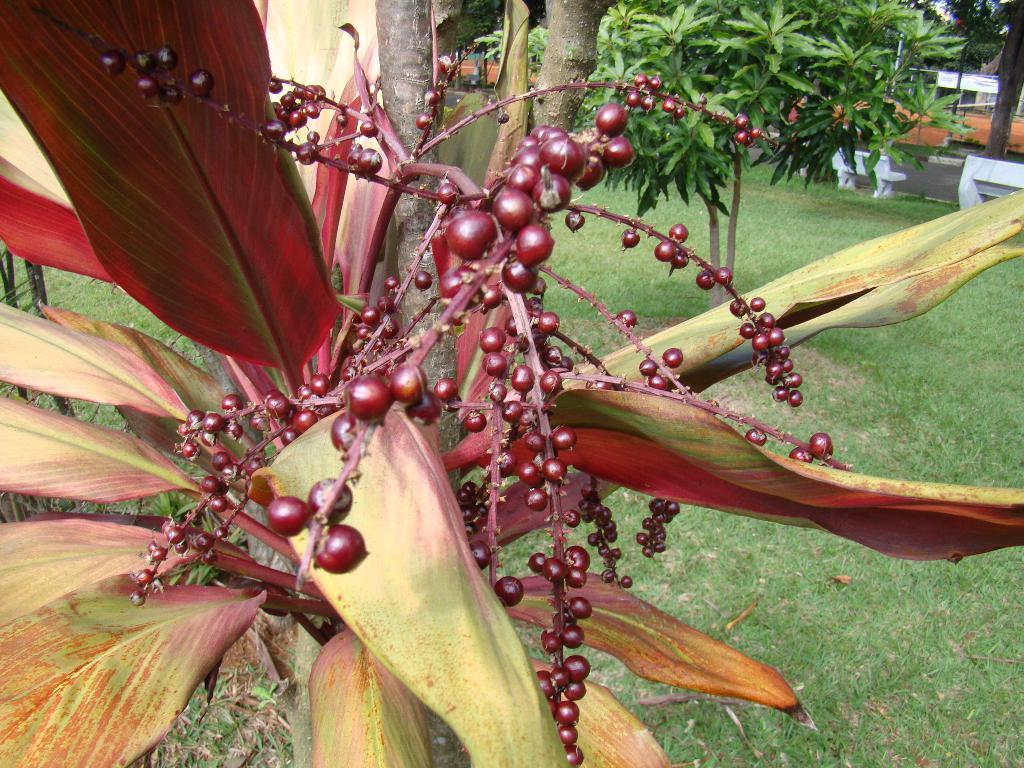What type of plant is visible in the image? There is a plant with fruits in the image. What is on the ground in the image? There is grass on the ground in the image. What can be seen in the background of the image? There are trees, a road, and benches in the background of the image. Can you see any forks in the image? There are no forks present in the image. Is the plant in the image growing near the sea? There is no sea visible in the image, and the plant is not near any body of water. 